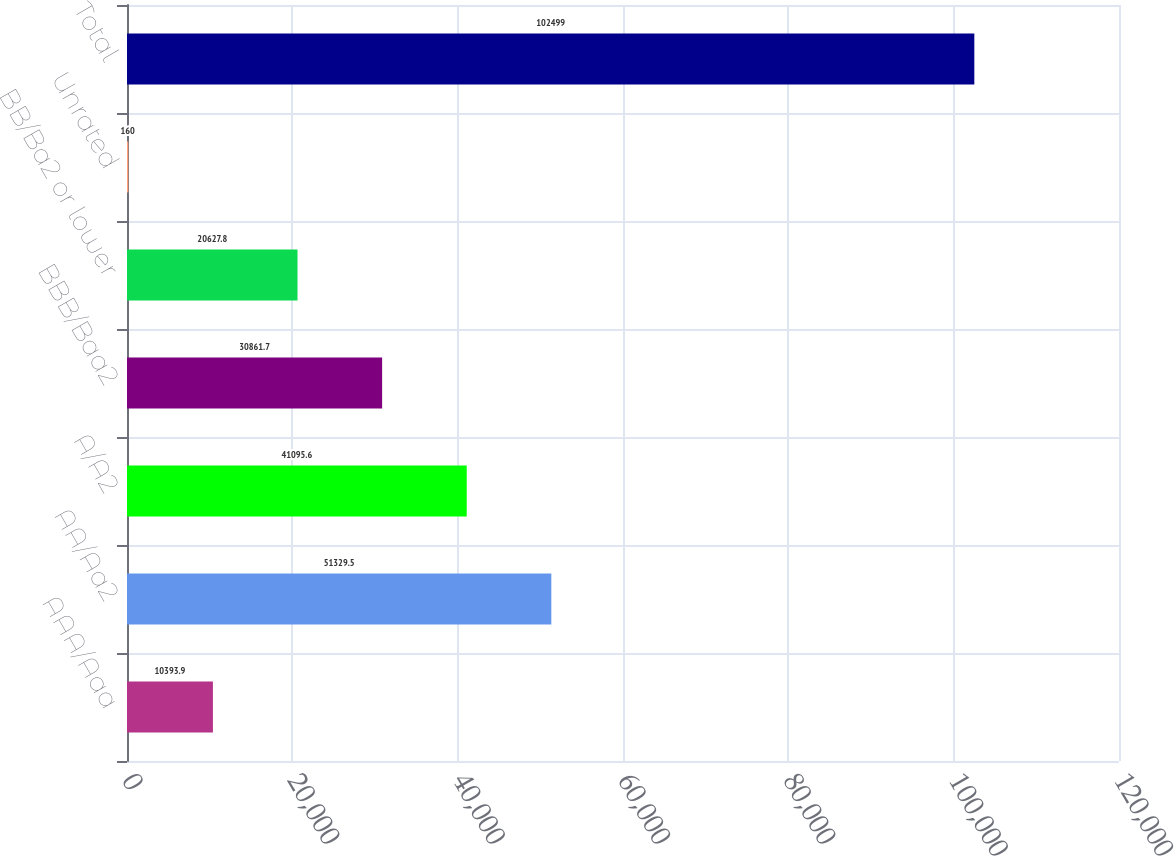Convert chart. <chart><loc_0><loc_0><loc_500><loc_500><bar_chart><fcel>AAA/Aaa<fcel>AA/Aa2<fcel>A/A2<fcel>BBB/Baa2<fcel>BB/Ba2 or lower<fcel>Unrated<fcel>Total<nl><fcel>10393.9<fcel>51329.5<fcel>41095.6<fcel>30861.7<fcel>20627.8<fcel>160<fcel>102499<nl></chart> 